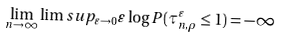<formula> <loc_0><loc_0><loc_500><loc_500>\lim _ { n \rightarrow \infty } \lim s u p _ { \varepsilon \rightarrow 0 } \varepsilon \log P ( \tau _ { n , \rho } ^ { \varepsilon } \leq 1 ) = - \infty</formula> 